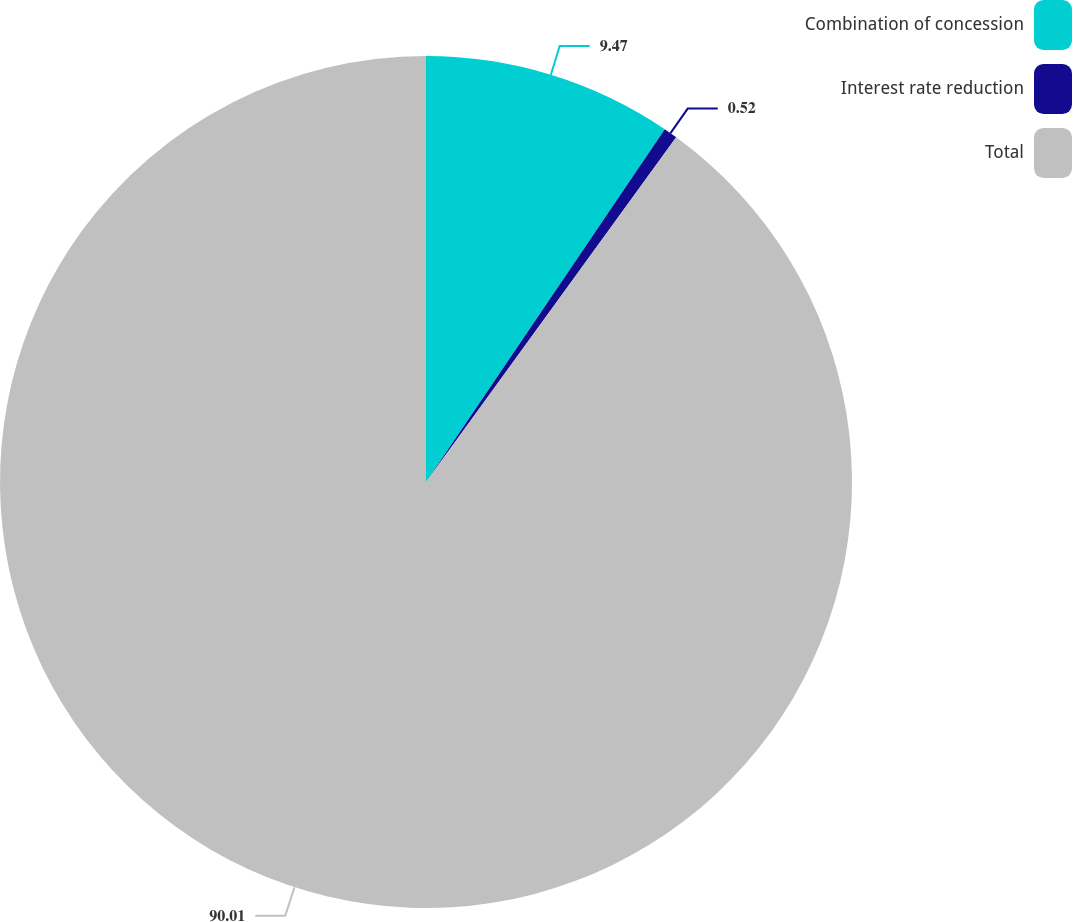Convert chart. <chart><loc_0><loc_0><loc_500><loc_500><pie_chart><fcel>Combination of concession<fcel>Interest rate reduction<fcel>Total<nl><fcel>9.47%<fcel>0.52%<fcel>90.01%<nl></chart> 